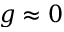Convert formula to latex. <formula><loc_0><loc_0><loc_500><loc_500>g \approx 0</formula> 